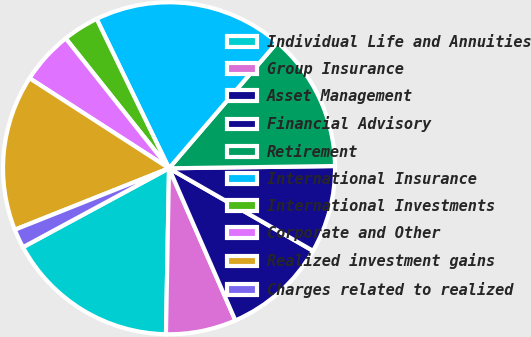Convert chart. <chart><loc_0><loc_0><loc_500><loc_500><pie_chart><fcel>Individual Life and Annuities<fcel>Group Insurance<fcel>Asset Management<fcel>Financial Advisory<fcel>Retirement<fcel>International Insurance<fcel>International Investments<fcel>Corporate and Other<fcel>Realized investment gains<fcel>Charges related to realized<nl><fcel>16.82%<fcel>6.84%<fcel>10.17%<fcel>8.5%<fcel>13.49%<fcel>18.48%<fcel>3.51%<fcel>5.18%<fcel>15.16%<fcel>1.85%<nl></chart> 